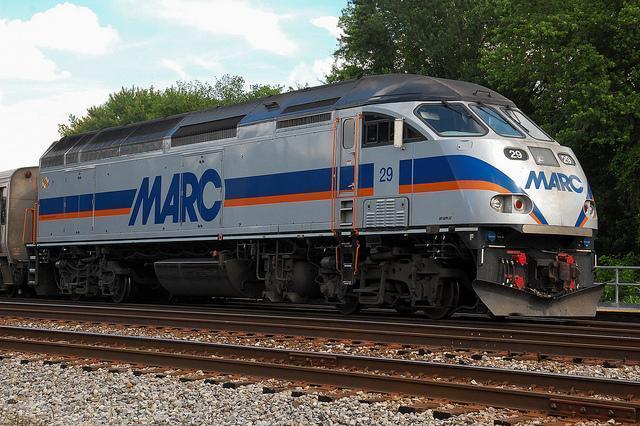How many times is the train number visible?
Give a very brief answer. 3. 